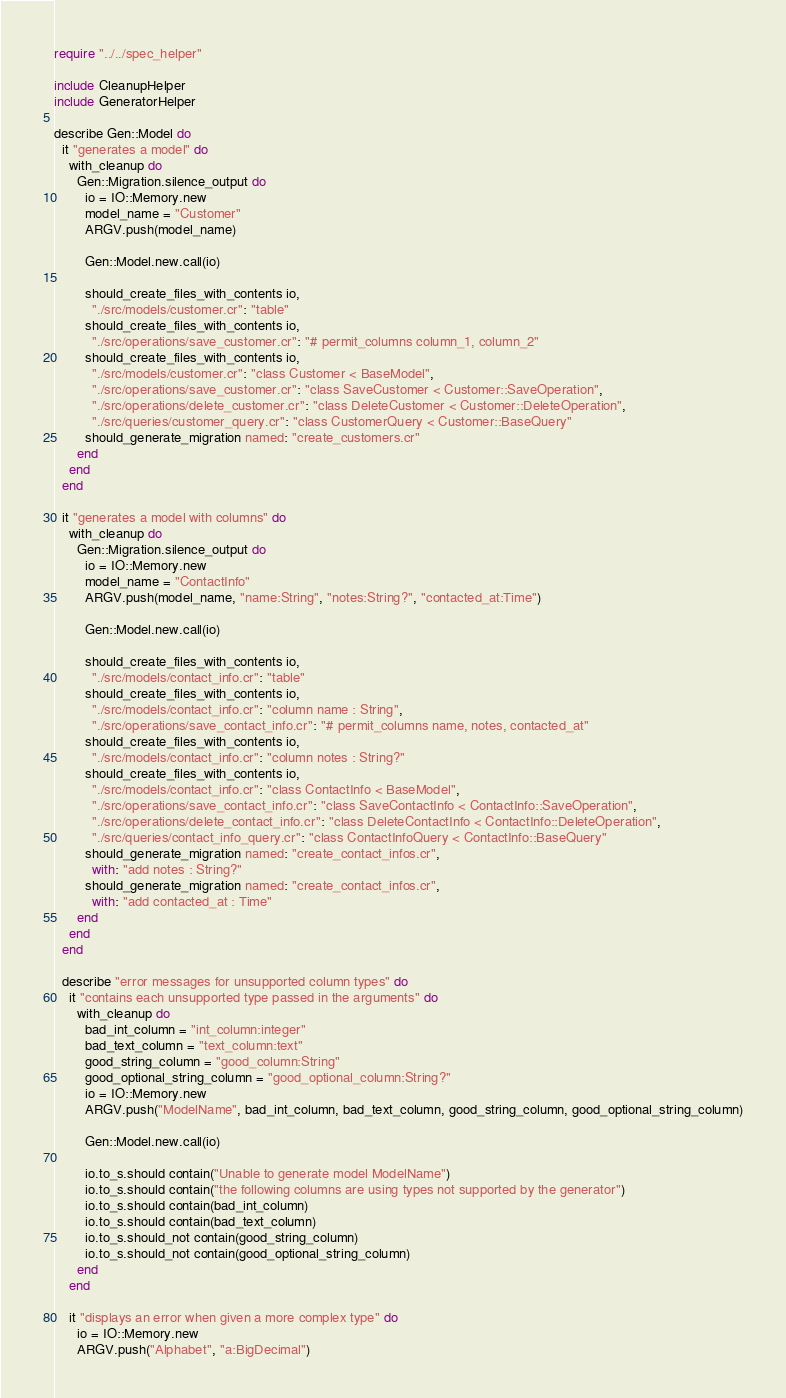Convert code to text. <code><loc_0><loc_0><loc_500><loc_500><_Crystal_>require "../../spec_helper"

include CleanupHelper
include GeneratorHelper

describe Gen::Model do
  it "generates a model" do
    with_cleanup do
      Gen::Migration.silence_output do
        io = IO::Memory.new
        model_name = "Customer"
        ARGV.push(model_name)

        Gen::Model.new.call(io)

        should_create_files_with_contents io,
          "./src/models/customer.cr": "table"
        should_create_files_with_contents io,
          "./src/operations/save_customer.cr": "# permit_columns column_1, column_2"
        should_create_files_with_contents io,
          "./src/models/customer.cr": "class Customer < BaseModel",
          "./src/operations/save_customer.cr": "class SaveCustomer < Customer::SaveOperation",
          "./src/operations/delete_customer.cr": "class DeleteCustomer < Customer::DeleteOperation",
          "./src/queries/customer_query.cr": "class CustomerQuery < Customer::BaseQuery"
        should_generate_migration named: "create_customers.cr"
      end
    end
  end

  it "generates a model with columns" do
    with_cleanup do
      Gen::Migration.silence_output do
        io = IO::Memory.new
        model_name = "ContactInfo"
        ARGV.push(model_name, "name:String", "notes:String?", "contacted_at:Time")

        Gen::Model.new.call(io)

        should_create_files_with_contents io,
          "./src/models/contact_info.cr": "table"
        should_create_files_with_contents io,
          "./src/models/contact_info.cr": "column name : String",
          "./src/operations/save_contact_info.cr": "# permit_columns name, notes, contacted_at"
        should_create_files_with_contents io,
          "./src/models/contact_info.cr": "column notes : String?"
        should_create_files_with_contents io,
          "./src/models/contact_info.cr": "class ContactInfo < BaseModel",
          "./src/operations/save_contact_info.cr": "class SaveContactInfo < ContactInfo::SaveOperation",
          "./src/operations/delete_contact_info.cr": "class DeleteContactInfo < ContactInfo::DeleteOperation",
          "./src/queries/contact_info_query.cr": "class ContactInfoQuery < ContactInfo::BaseQuery"
        should_generate_migration named: "create_contact_infos.cr",
          with: "add notes : String?"
        should_generate_migration named: "create_contact_infos.cr",
          with: "add contacted_at : Time"
      end
    end
  end

  describe "error messages for unsupported column types" do
    it "contains each unsupported type passed in the arguments" do
      with_cleanup do
        bad_int_column = "int_column:integer"
        bad_text_column = "text_column:text"
        good_string_column = "good_column:String"
        good_optional_string_column = "good_optional_column:String?"
        io = IO::Memory.new
        ARGV.push("ModelName", bad_int_column, bad_text_column, good_string_column, good_optional_string_column)

        Gen::Model.new.call(io)

        io.to_s.should contain("Unable to generate model ModelName")
        io.to_s.should contain("the following columns are using types not supported by the generator")
        io.to_s.should contain(bad_int_column)
        io.to_s.should contain(bad_text_column)
        io.to_s.should_not contain(good_string_column)
        io.to_s.should_not contain(good_optional_string_column)
      end
    end

    it "displays an error when given a more complex type" do
      io = IO::Memory.new
      ARGV.push("Alphabet", "a:BigDecimal")
</code> 